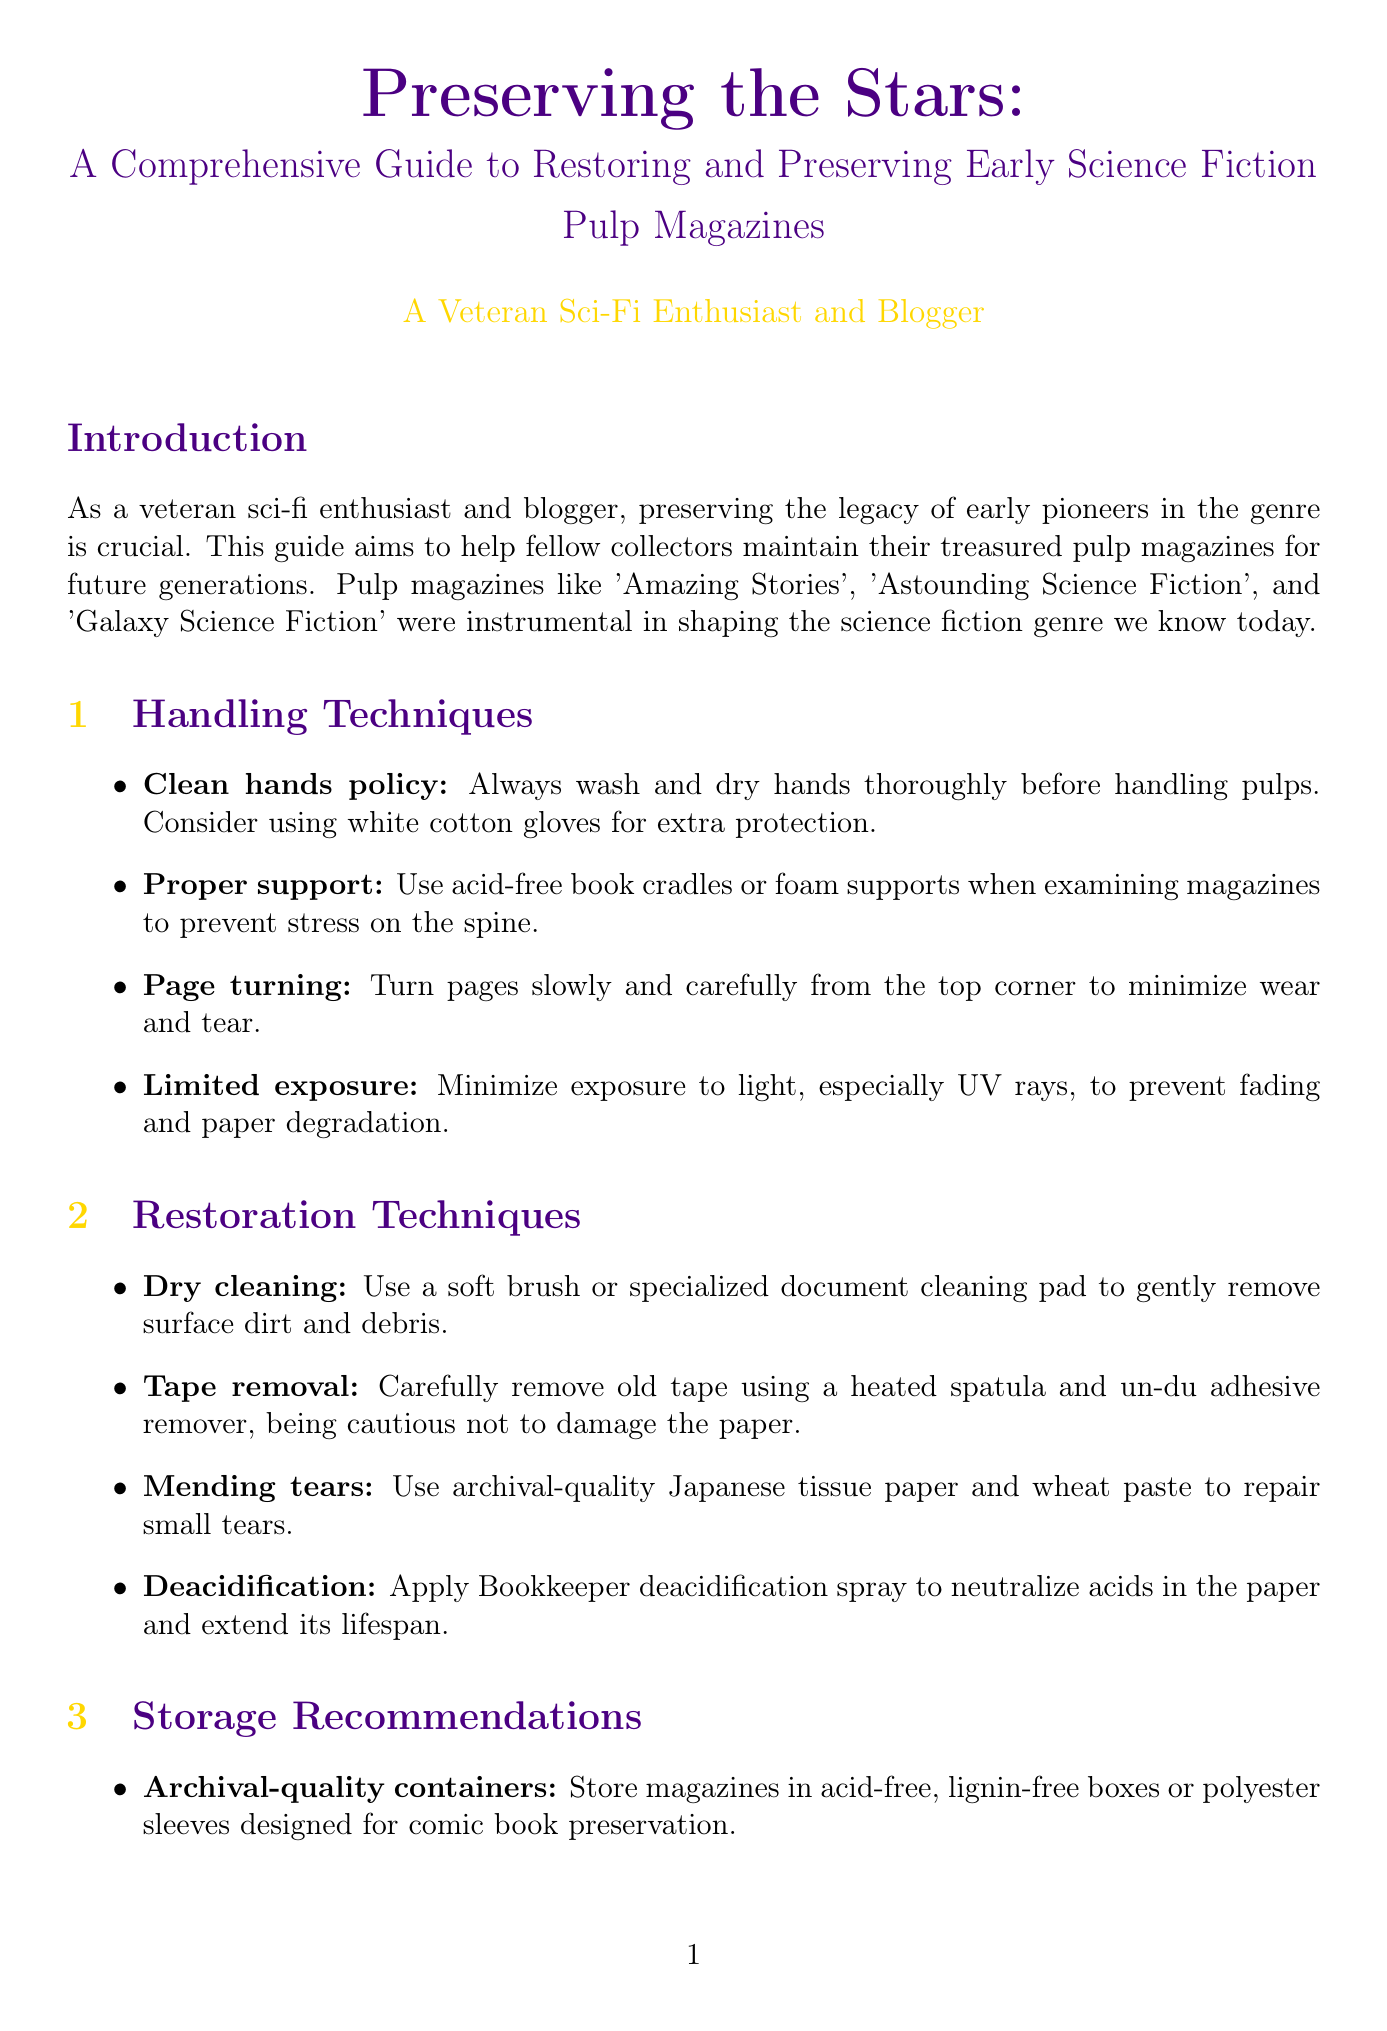What are acid-free containers used for? Acid-free containers are recommended for storing magazines to prevent deterioration.
Answer: Archival-quality containers What is the recommended humidity level for storing pulp magazines? The document advises maintaining relative humidity between 30-50% for proper storage conditions.
Answer: 30-50% Which museum features an extensive collection of pulp magazines? The document mentions two notable collections, one of which holds a significant number of pulp magazines.
Answer: Maison d'Ailleurs What technique should be used to gently remove surface dirt? The document outlines a specific method for cleaning that involves using a particular tool.
Answer: Dry cleaning What is the ideal temperature for climate control? The guide suggests a temperature to maintain for the proper storage of magazines.
Answer: 65°F (18°C) How can digital backups be created from the collection? The document describes a method involving a specific type of scanner with a required resolution.
Answer: High-quality flatbed scanner with at least 600 dpi Why is it important to use cotton gloves? The guide explains that gloves provide an additional safeguard when handling delicate materials.
Answer: Clean hands policy What should be used to separate magazines during storage? The document specifies a material recommended to prevent ink transfer between covers.
Answer: Acid-free paper or thin cardboard How should pages be turned to minimize wear? The document provides a recommended technique for page turning in order to protect the magazines.
Answer: From the top corner 